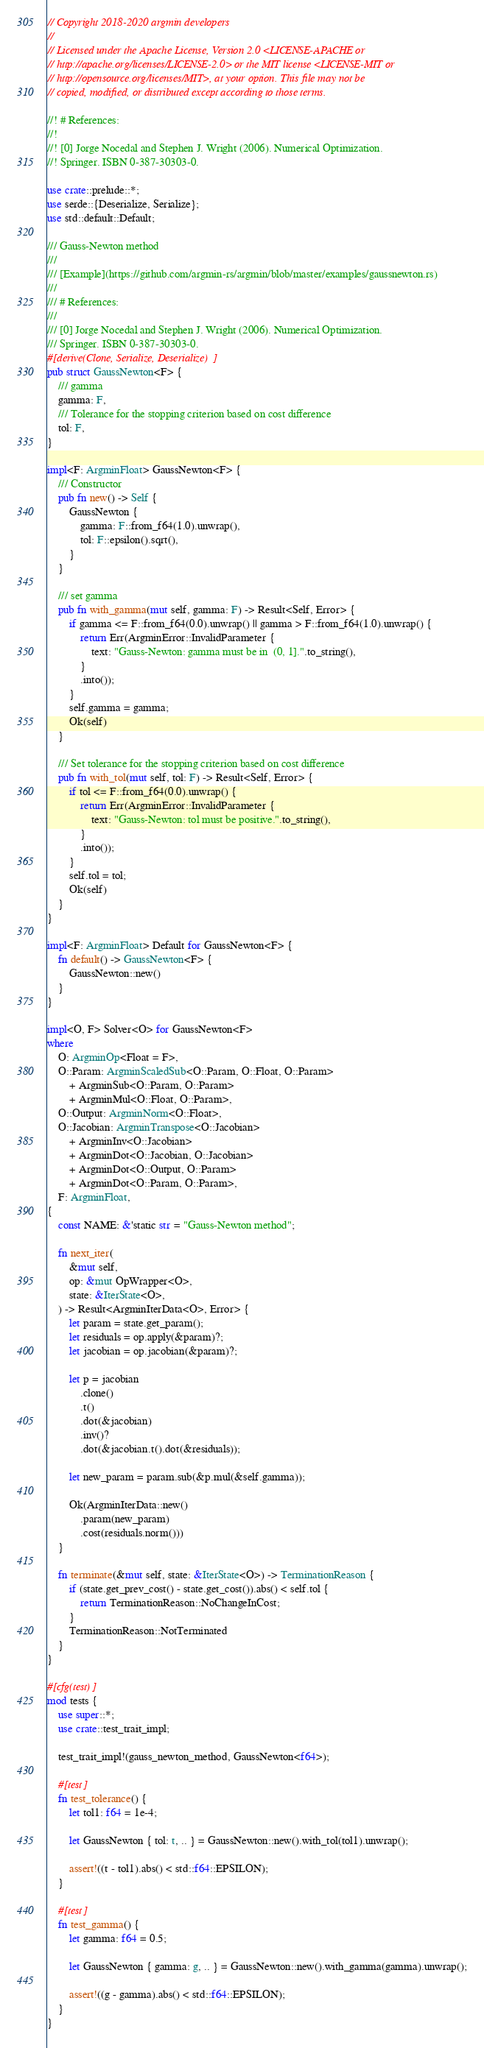<code> <loc_0><loc_0><loc_500><loc_500><_Rust_>// Copyright 2018-2020 argmin developers
//
// Licensed under the Apache License, Version 2.0 <LICENSE-APACHE or
// http://apache.org/licenses/LICENSE-2.0> or the MIT license <LICENSE-MIT or
// http://opensource.org/licenses/MIT>, at your option. This file may not be
// copied, modified, or distributed except according to those terms.

//! # References:
//!
//! [0] Jorge Nocedal and Stephen J. Wright (2006). Numerical Optimization.
//! Springer. ISBN 0-387-30303-0.

use crate::prelude::*;
use serde::{Deserialize, Serialize};
use std::default::Default;

/// Gauss-Newton method
///
/// [Example](https://github.com/argmin-rs/argmin/blob/master/examples/gaussnewton.rs)
///
/// # References:
///
/// [0] Jorge Nocedal and Stephen J. Wright (2006). Numerical Optimization.
/// Springer. ISBN 0-387-30303-0.
#[derive(Clone, Serialize, Deserialize)]
pub struct GaussNewton<F> {
    /// gamma
    gamma: F,
    /// Tolerance for the stopping criterion based on cost difference
    tol: F,
}

impl<F: ArgminFloat> GaussNewton<F> {
    /// Constructor
    pub fn new() -> Self {
        GaussNewton {
            gamma: F::from_f64(1.0).unwrap(),
            tol: F::epsilon().sqrt(),
        }
    }

    /// set gamma
    pub fn with_gamma(mut self, gamma: F) -> Result<Self, Error> {
        if gamma <= F::from_f64(0.0).unwrap() || gamma > F::from_f64(1.0).unwrap() {
            return Err(ArgminError::InvalidParameter {
                text: "Gauss-Newton: gamma must be in  (0, 1].".to_string(),
            }
            .into());
        }
        self.gamma = gamma;
        Ok(self)
    }

    /// Set tolerance for the stopping criterion based on cost difference
    pub fn with_tol(mut self, tol: F) -> Result<Self, Error> {
        if tol <= F::from_f64(0.0).unwrap() {
            return Err(ArgminError::InvalidParameter {
                text: "Gauss-Newton: tol must be positive.".to_string(),
            }
            .into());
        }
        self.tol = tol;
        Ok(self)
    }
}

impl<F: ArgminFloat> Default for GaussNewton<F> {
    fn default() -> GaussNewton<F> {
        GaussNewton::new()
    }
}

impl<O, F> Solver<O> for GaussNewton<F>
where
    O: ArgminOp<Float = F>,
    O::Param: ArgminScaledSub<O::Param, O::Float, O::Param>
        + ArgminSub<O::Param, O::Param>
        + ArgminMul<O::Float, O::Param>,
    O::Output: ArgminNorm<O::Float>,
    O::Jacobian: ArgminTranspose<O::Jacobian>
        + ArgminInv<O::Jacobian>
        + ArgminDot<O::Jacobian, O::Jacobian>
        + ArgminDot<O::Output, O::Param>
        + ArgminDot<O::Param, O::Param>,
    F: ArgminFloat,
{
    const NAME: &'static str = "Gauss-Newton method";

    fn next_iter(
        &mut self,
        op: &mut OpWrapper<O>,
        state: &IterState<O>,
    ) -> Result<ArgminIterData<O>, Error> {
        let param = state.get_param();
        let residuals = op.apply(&param)?;
        let jacobian = op.jacobian(&param)?;

        let p = jacobian
            .clone()
            .t()
            .dot(&jacobian)
            .inv()?
            .dot(&jacobian.t().dot(&residuals));

        let new_param = param.sub(&p.mul(&self.gamma));

        Ok(ArgminIterData::new()
            .param(new_param)
            .cost(residuals.norm()))
    }

    fn terminate(&mut self, state: &IterState<O>) -> TerminationReason {
        if (state.get_prev_cost() - state.get_cost()).abs() < self.tol {
            return TerminationReason::NoChangeInCost;
        }
        TerminationReason::NotTerminated
    }
}

#[cfg(test)]
mod tests {
    use super::*;
    use crate::test_trait_impl;

    test_trait_impl!(gauss_newton_method, GaussNewton<f64>);

    #[test]
    fn test_tolerance() {
        let tol1: f64 = 1e-4;

        let GaussNewton { tol: t, .. } = GaussNewton::new().with_tol(tol1).unwrap();

        assert!((t - tol1).abs() < std::f64::EPSILON);
    }

    #[test]
    fn test_gamma() {
        let gamma: f64 = 0.5;

        let GaussNewton { gamma: g, .. } = GaussNewton::new().with_gamma(gamma).unwrap();

        assert!((g - gamma).abs() < std::f64::EPSILON);
    }
}
</code> 